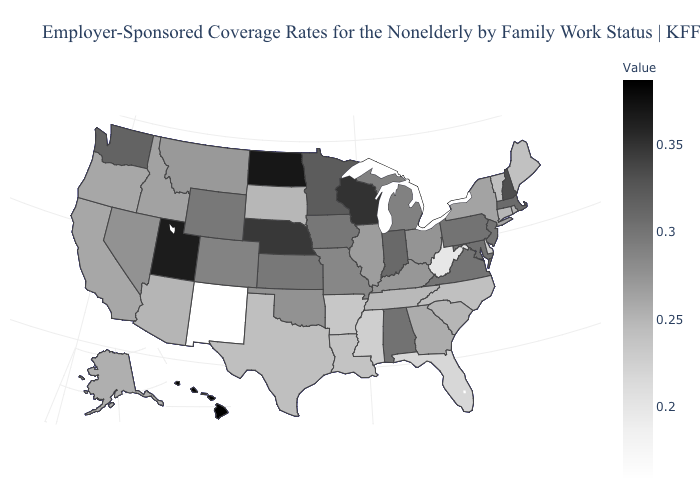Does Idaho have the lowest value in the USA?
Be succinct. No. Does South Dakota have the lowest value in the MidWest?
Write a very short answer. Yes. Among the states that border Pennsylvania , does Delaware have the highest value?
Keep it brief. No. Among the states that border North Dakota , which have the highest value?
Keep it brief. Minnesota. Does Montana have a lower value than Utah?
Answer briefly. Yes. Does Delaware have a higher value than West Virginia?
Short answer required. Yes. Which states hav the highest value in the West?
Give a very brief answer. Hawaii. 